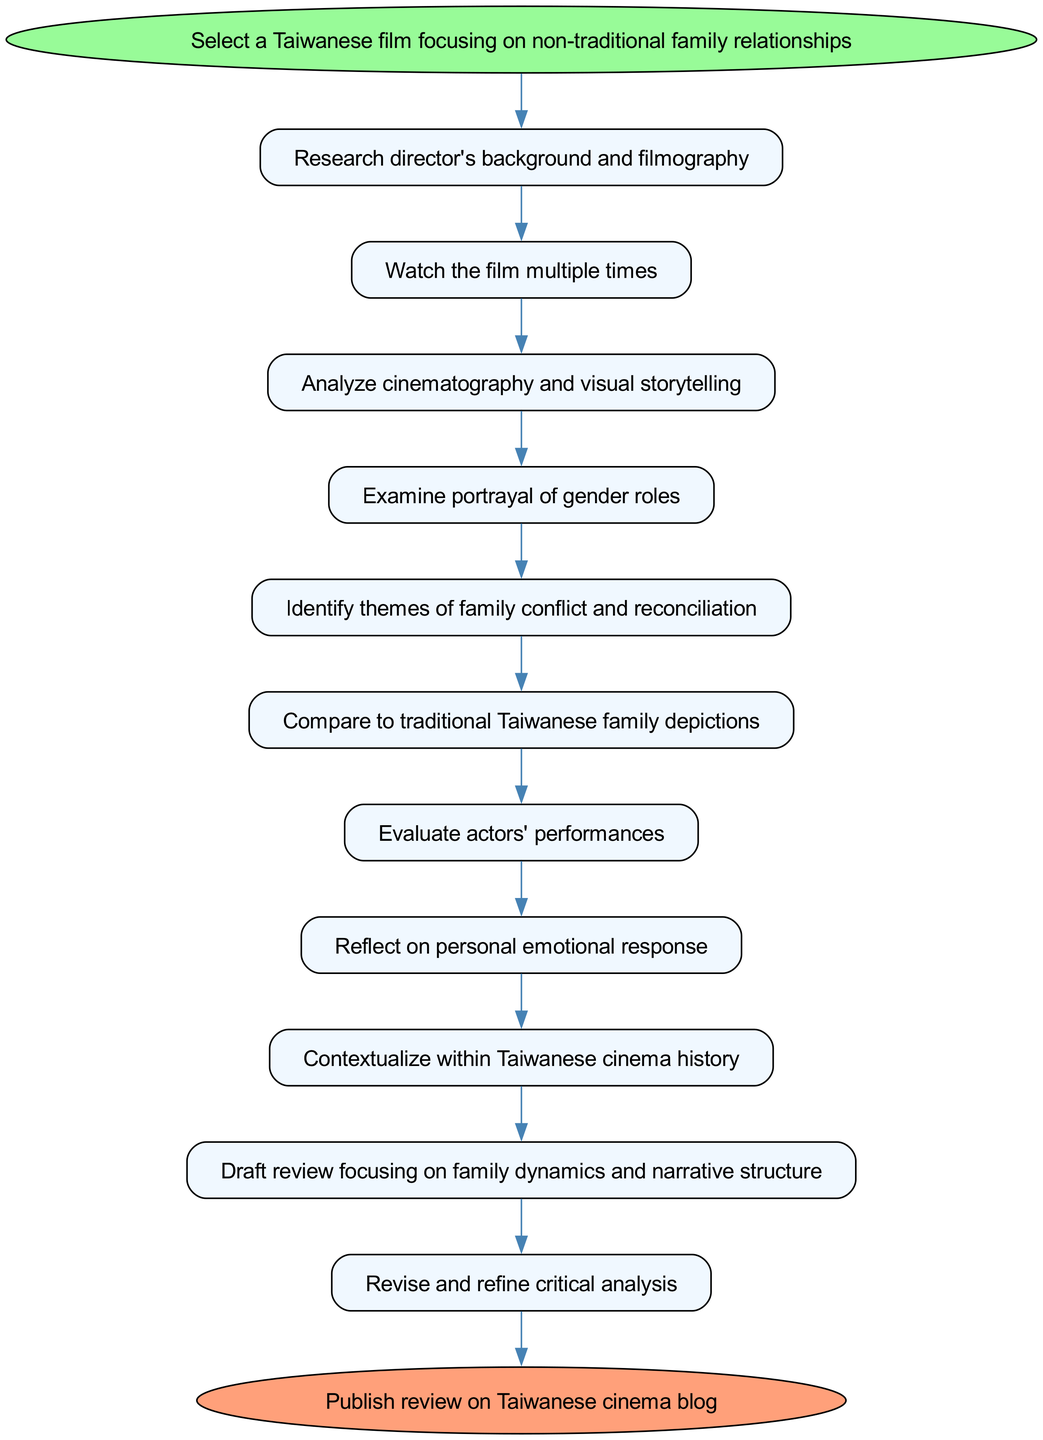What is the first step in the process? The first step is indicated in the "start" node and consists of selecting a Taiwanese film focusing on non-traditional family relationships.
Answer: Select a Taiwanese film focusing on non-traditional family relationships How many steps are there in total? The total number of steps can be counted directly from the diagram, which lists 10 steps in addition to the start and end nodes.
Answer: 10 What is the last step before publishing the review? The last step before reaching the end node involves revising and refining the critical analysis, which is the final process before publication.
Answer: Revise and refine critical analysis Which step directly follows the examination of gender roles? By looking at the flow of the process, the step that directly follows the examination of gender roles is the identification of themes of family conflict and reconciliation.
Answer: Identify themes of family conflict and reconciliation What color is the start node? The start node is indicated to be of a specific color which corresponds to light green in the diagram.
Answer: Light green Which steps involve personal reflection in the process? The steps that involve personal reflection are 'Reflect on personal emotional response' where the writer considers their feelings about the film.
Answer: Reflect on personal emotional response How does the drafting step relate to the steps prior? The drafting step is the culmination of the analysis and reflection phases, as it focuses on creating a review that emphasizes family dynamics and narrative structure built upon previous analyses.
Answer: It follows previous analysis and reflection phases Which step involves performance evaluation? The step that specifically focuses on actor evaluations is 'Evaluate actors' performances,' which occurs after analyzing cinematography and visual storytelling.
Answer: Evaluate actors' performances 